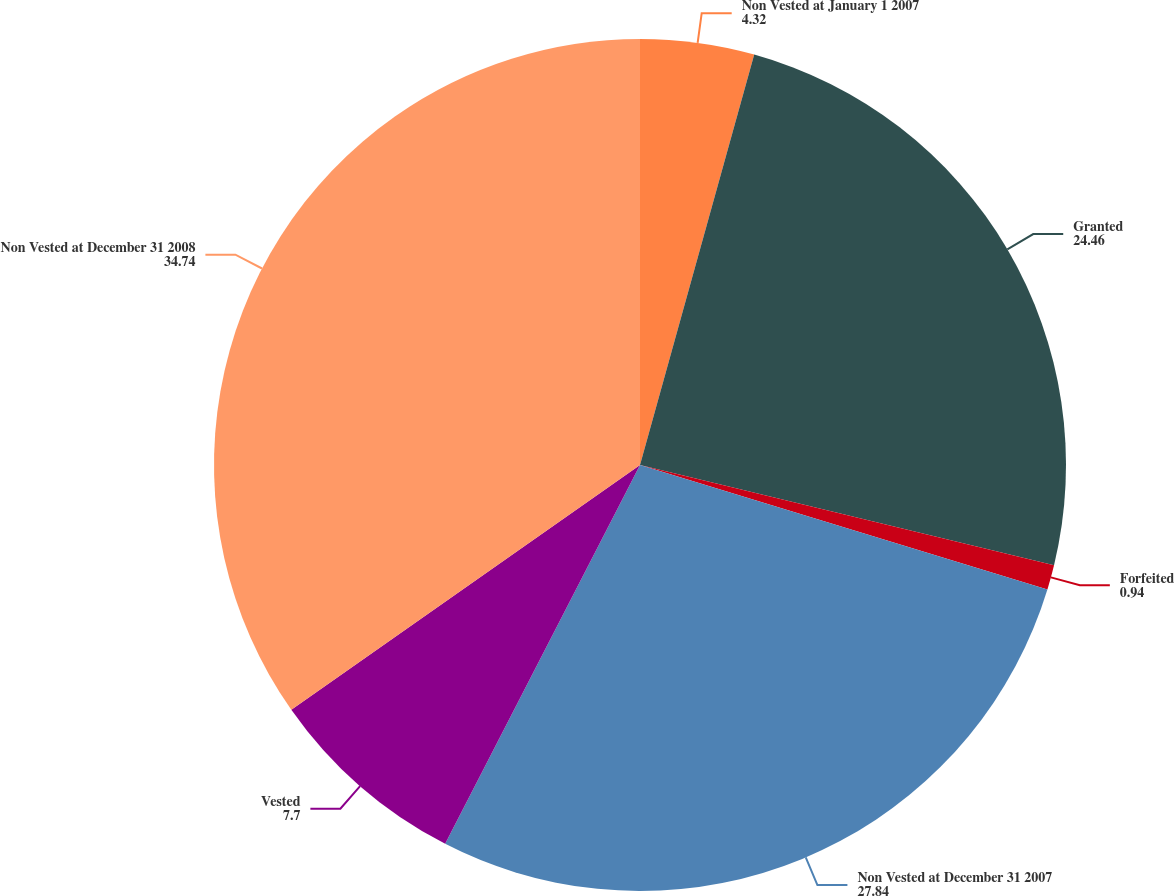<chart> <loc_0><loc_0><loc_500><loc_500><pie_chart><fcel>Non Vested at January 1 2007<fcel>Granted<fcel>Forfeited<fcel>Non Vested at December 31 2007<fcel>Vested<fcel>Non Vested at December 31 2008<nl><fcel>4.32%<fcel>24.46%<fcel>0.94%<fcel>27.84%<fcel>7.7%<fcel>34.74%<nl></chart> 